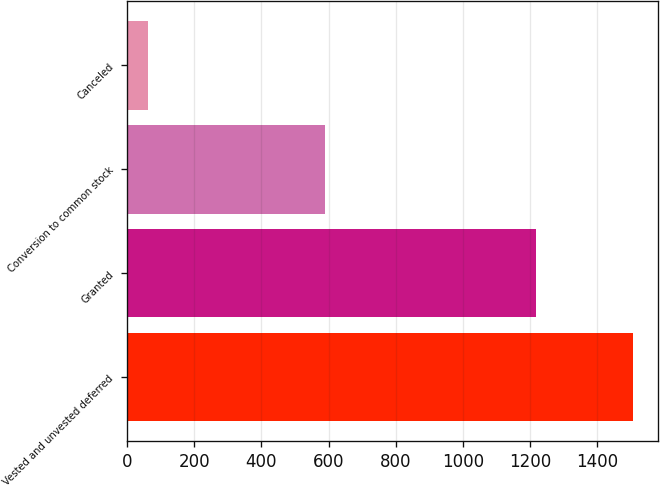Convert chart to OTSL. <chart><loc_0><loc_0><loc_500><loc_500><bar_chart><fcel>Vested and unvested deferred<fcel>Granted<fcel>Conversion to common stock<fcel>Canceled<nl><fcel>1507<fcel>1219.6<fcel>588<fcel>61<nl></chart> 